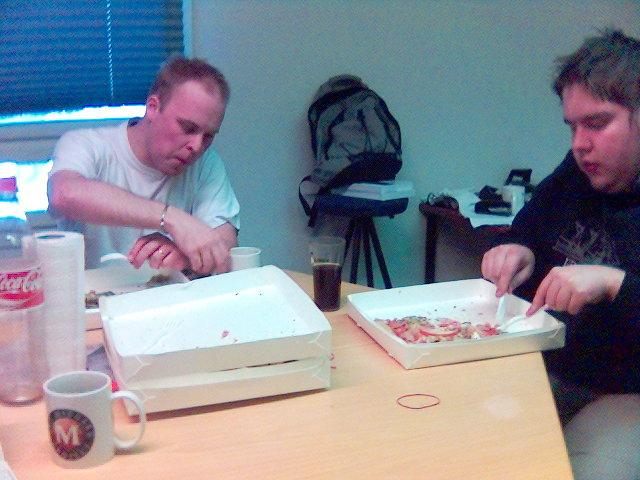What type of beverages are being consumed by the pizza eater?

Choices:
A) beer
B) wine
C) milkshakes
D) soft drinks soft drinks 